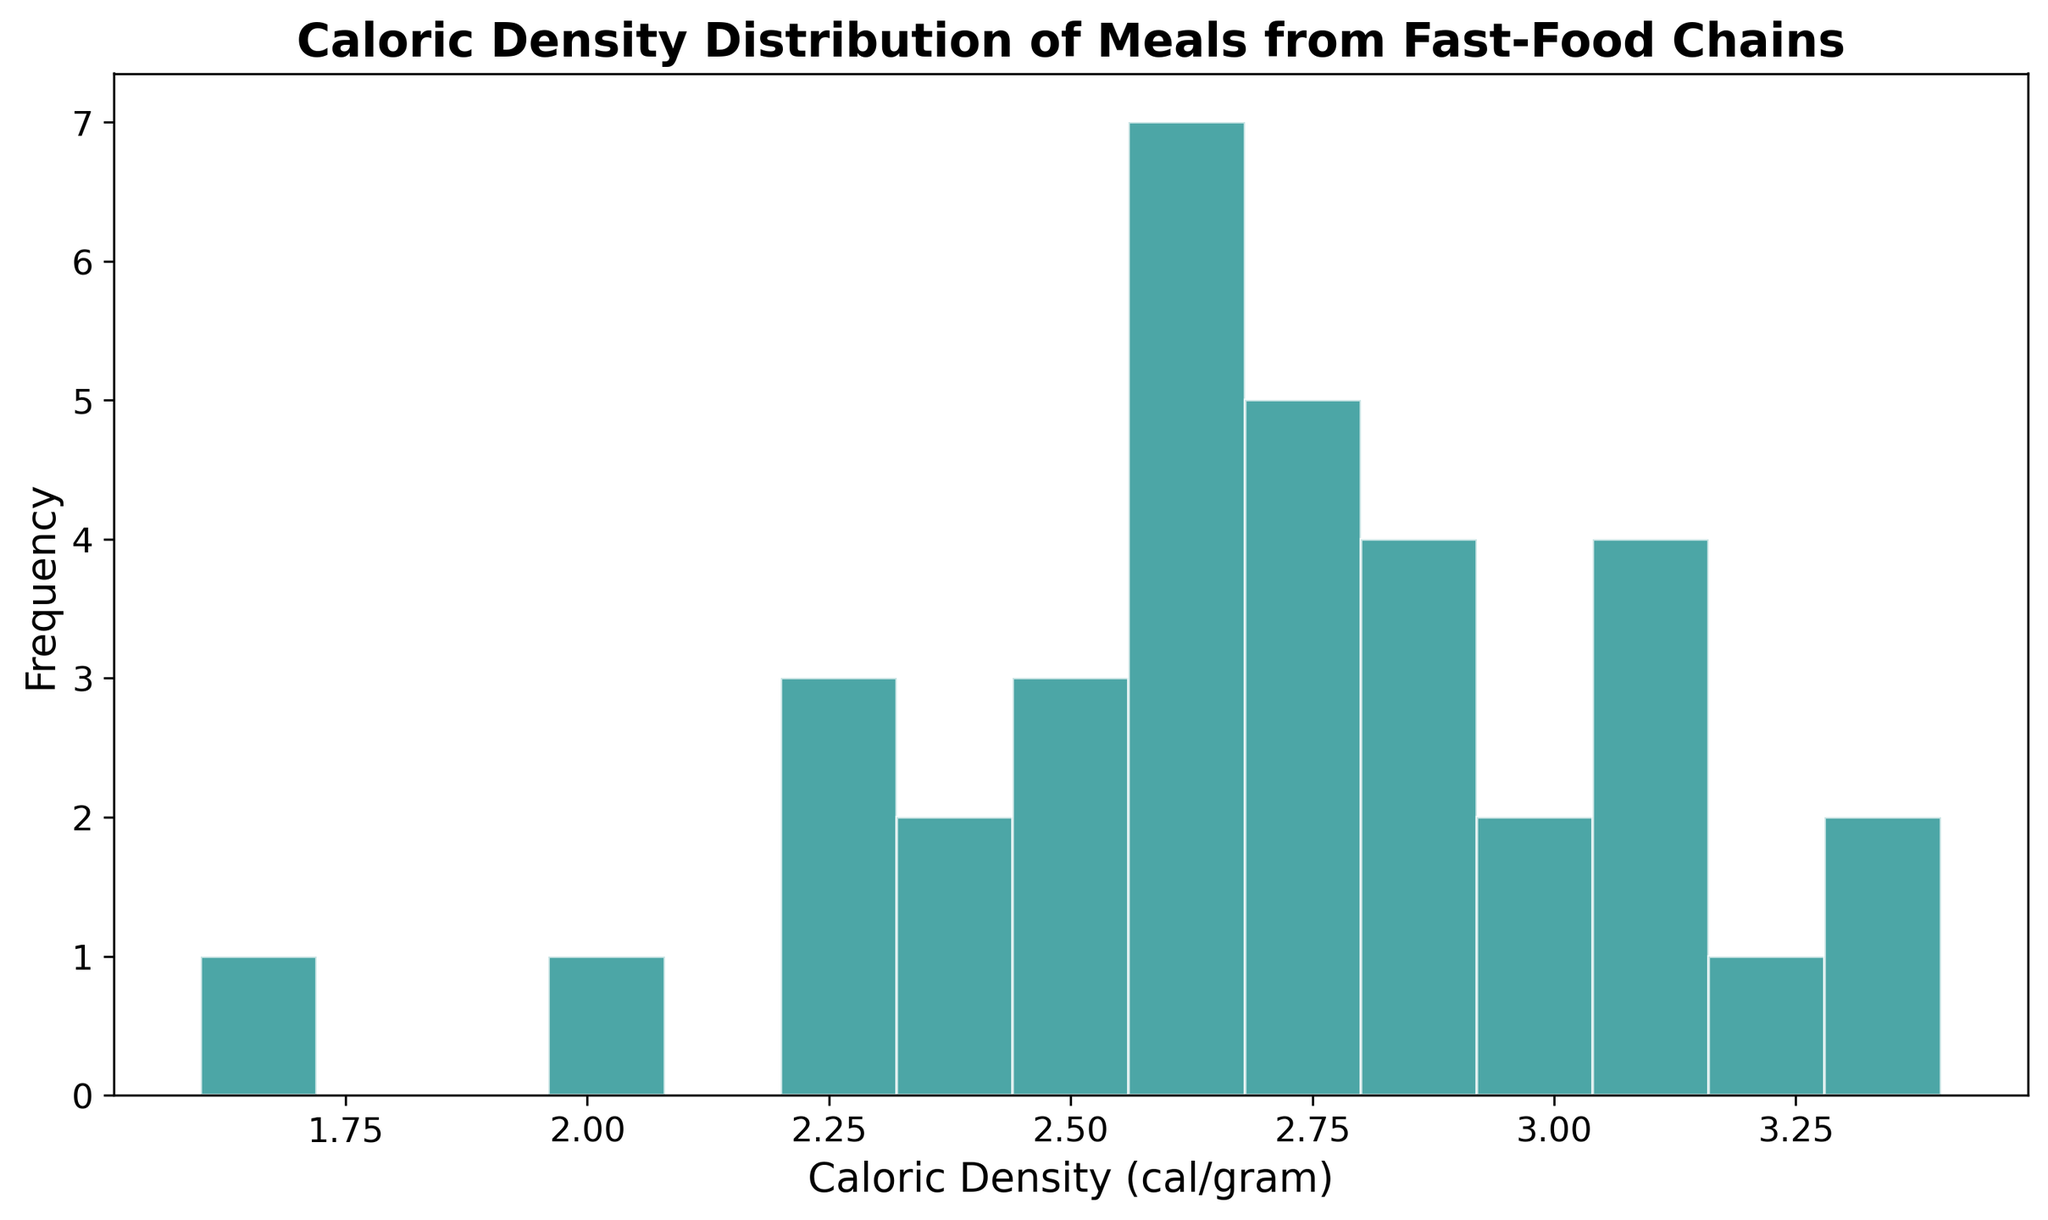What is the most frequent caloric density range in the histogram? By visually inspecting the height of the bars, observe which range of caloric density (represented by a specific bin) has the tallest bar, indicating the highest frequency.
Answer: The 2.5-2.75 cal/gram range Which caloric density range has the fewest meals? Look for the shortest bar in the histogram, representing the range with the least frequency of caloric density.
Answer: The 1.5-1.75 cal/gram range How many meals have a caloric density between 2.75 and 3.0 cal/gram? This requires counting the frequency (height of the bar) for the bin representing the 2.75-3.0 cal/gram range.
Answer: 4 meals Is there a larger frequency of meals with a caloric density above 3.0 cal/gram or below 2.0 cal/gram? Compare the heights of the bars representing caloric densities above 3.0 cal/gram and those representing below 2.0 cal/gram.
Answer: Above 3.0 cal/gram What is the approximate average caloric density of meals shown in the histogram? Average caloric density can be roughly estimated by visually identifying the central tendency (mean) of the distribution, focusing on the areas under the most frequent bins.
Answer: Around 2.7 cal/gram 